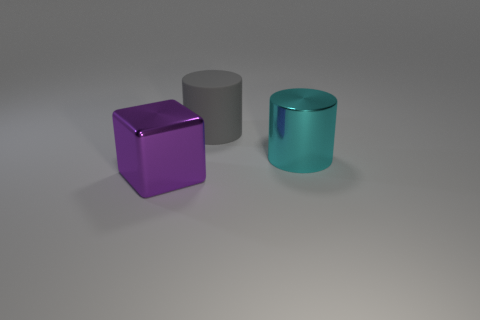What is the size of the object that is in front of the large matte cylinder and behind the large purple block?
Your response must be concise. Large. There is a purple object; does it have the same shape as the thing behind the cyan cylinder?
Give a very brief answer. No. The other cyan thing that is the same shape as the big matte thing is what size?
Provide a succinct answer. Large. Is the color of the big matte thing the same as the cylinder in front of the big rubber object?
Give a very brief answer. No. There is a shiny object that is right of the object that is in front of the shiny thing on the right side of the gray rubber object; what shape is it?
Provide a short and direct response. Cylinder. Do the purple thing and the cylinder that is left of the shiny cylinder have the same size?
Give a very brief answer. Yes. There is a thing that is both in front of the large rubber cylinder and left of the big cyan metallic thing; what is its color?
Offer a terse response. Purple. What number of other things are the same shape as the large purple thing?
Provide a short and direct response. 0. Is the color of the big metallic object on the left side of the cyan metallic cylinder the same as the metal thing behind the purple metal cube?
Make the answer very short. No. Do the purple thing in front of the matte object and the shiny thing behind the purple shiny block have the same size?
Make the answer very short. Yes. 